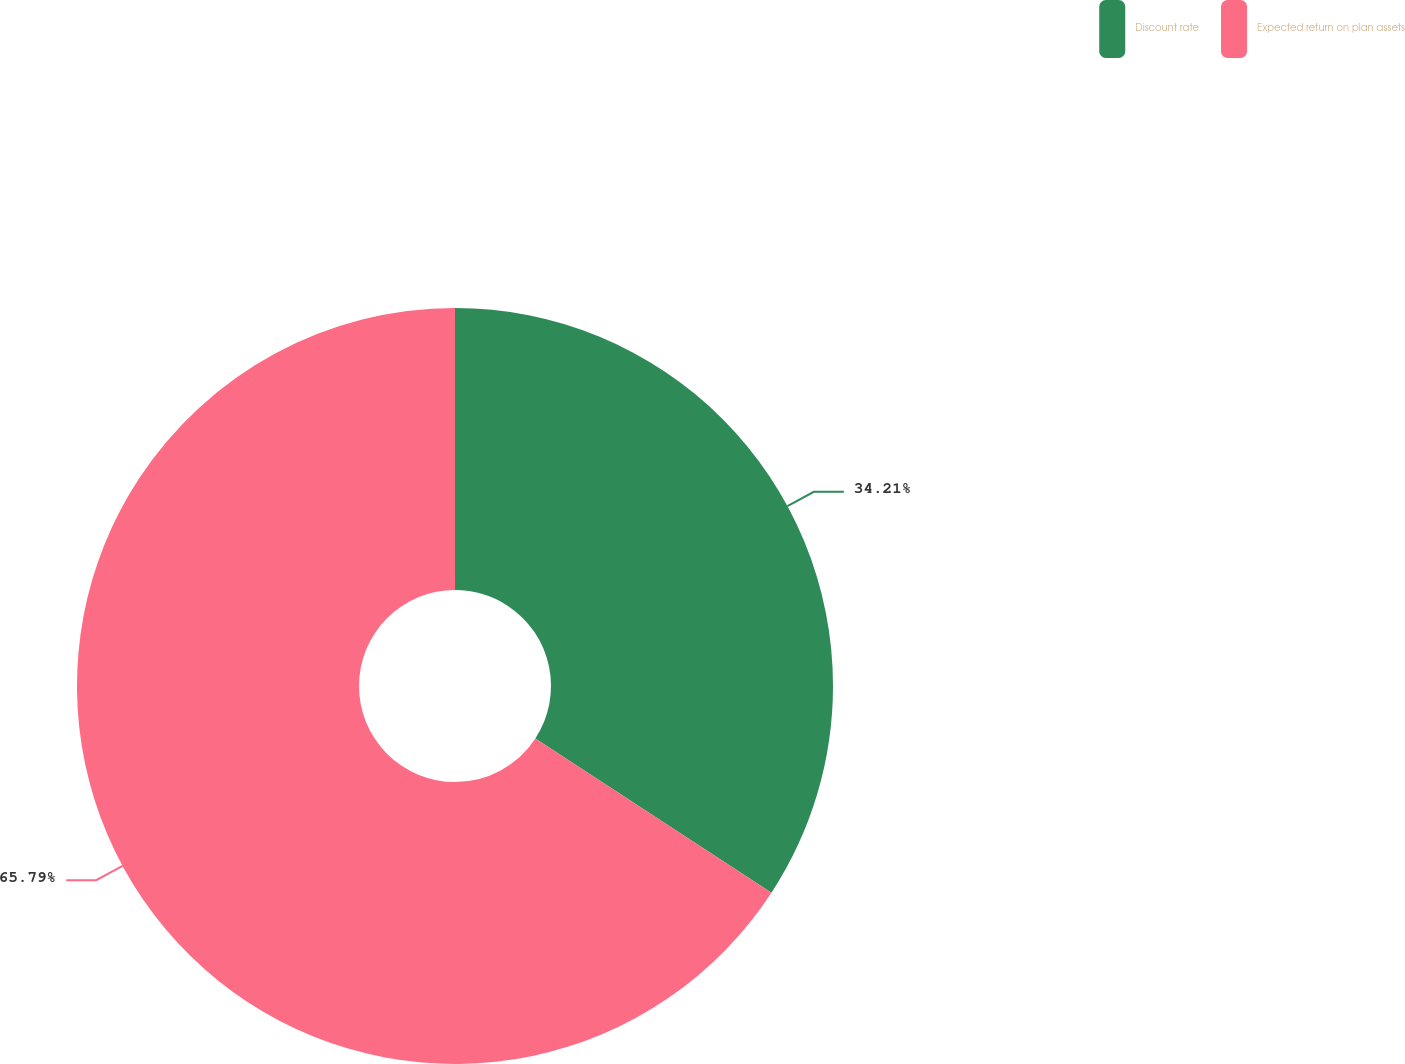Convert chart. <chart><loc_0><loc_0><loc_500><loc_500><pie_chart><fcel>Discount rate<fcel>Expected return on plan assets<nl><fcel>34.21%<fcel>65.79%<nl></chart> 